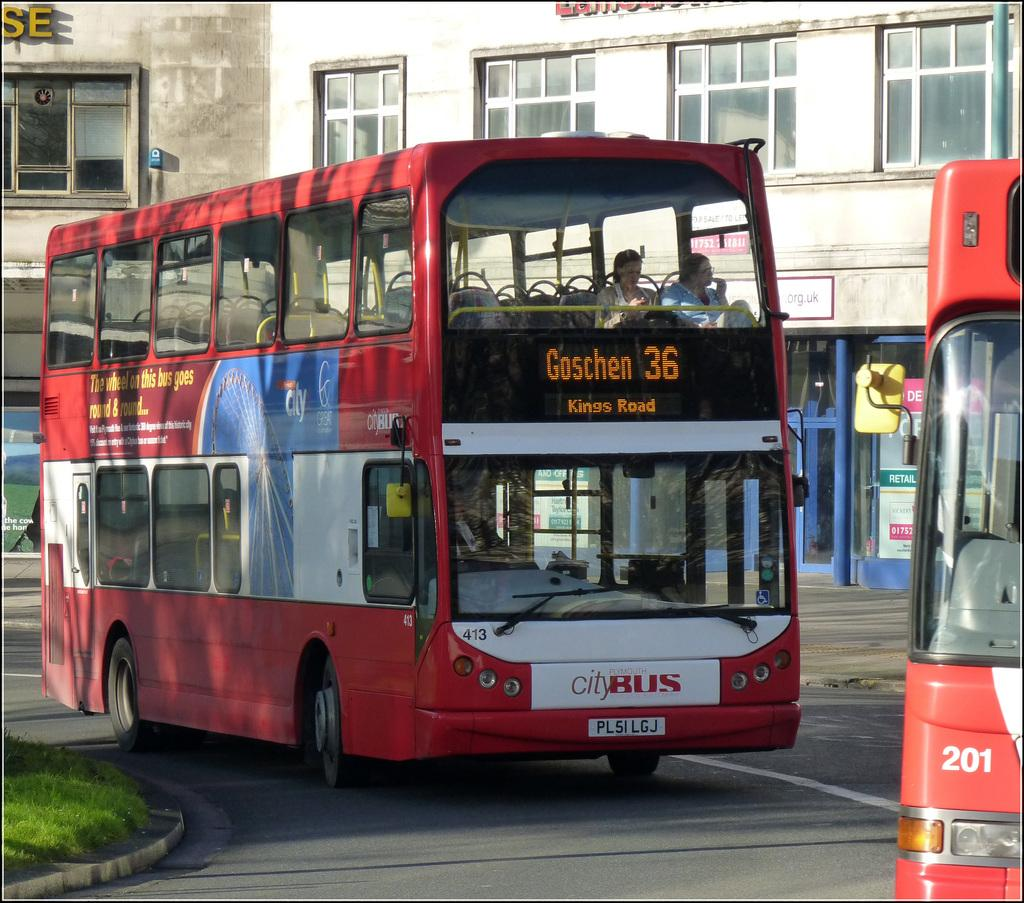<image>
Write a terse but informative summary of the picture. Red double decker city bus Goschen 36 Kings Road 